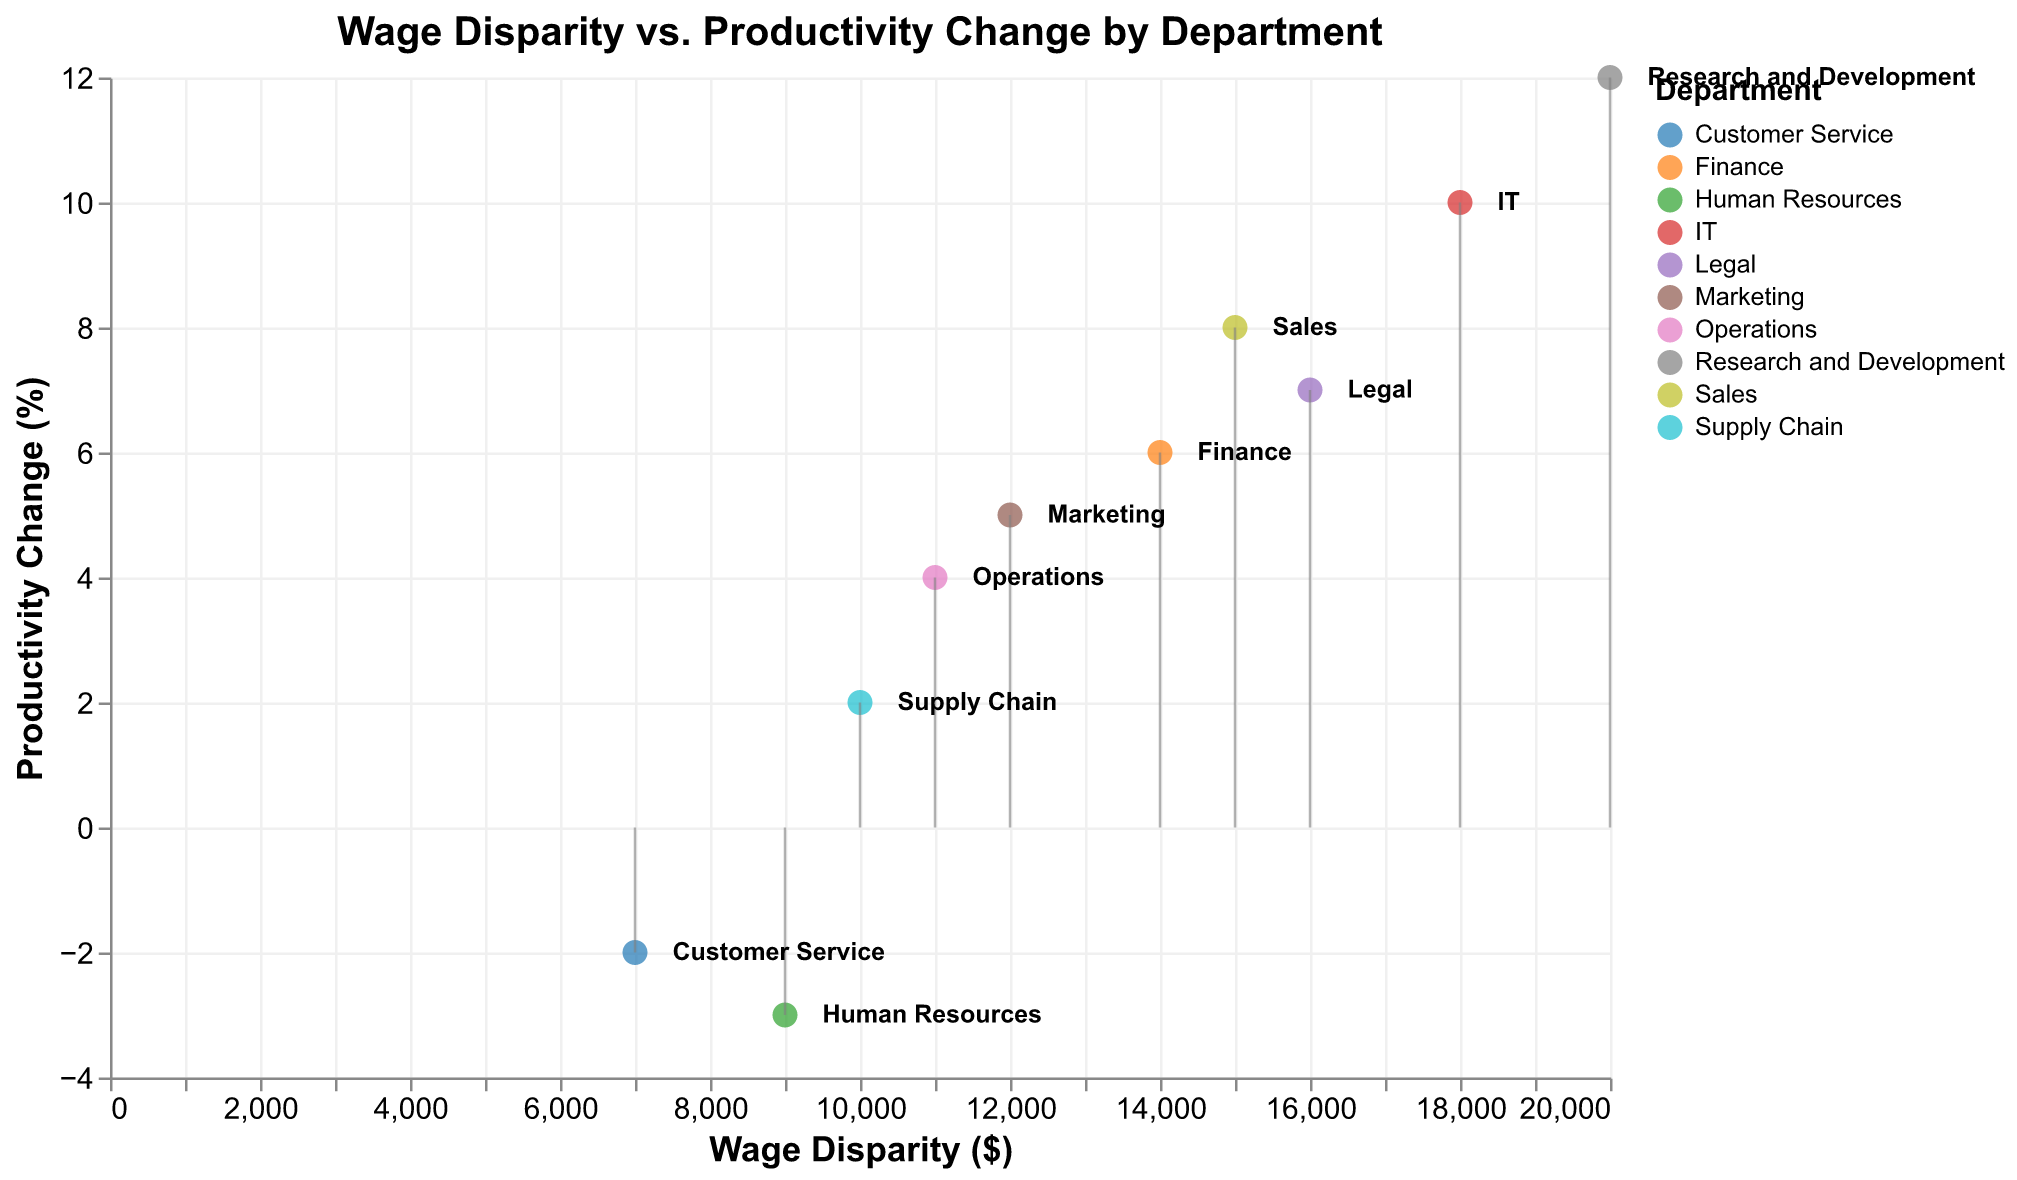What is the title of the figure? The title of the figure is displayed at the top of the graph and it usually provides the main topic or summary of what the figure represents.
Answer: Wage Disparity vs. Productivity Change by Department How many departments are represented in the figure? Count the number of distinct data points or labels on the plot. Each unique label or color represents a department.
Answer: 10 Which department has the highest wage disparity and what is the value? Look for the data point that is furthest to the right on the x-axis, which represents wage disparity, and identify the department.
Answer: Research and Development, $20,000 Which departments indicate a negative productivity change? Look for the data points below the y-axis origin (0%). Identify the labels or colors representing these departments.
Answer: Human Resources, Customer Service What is the productivity change percentage for the Finance department? Locate the point or label representing the Finance department and note its position on the y-axis.
Answer: 6% What is the difference in productivity change between Sales and Marketing departments? Find the y-axis values for both Sales and Marketing, subtract Marketing's value from Sales'.
Answer: 8% - 5% = 3% Do departments with higher wage disparity tend to have higher productivity changes? Observe the general trend or direction from left to right along the x-axis (wage disparity) and note if the points also increase upwards along the y-axis (productivity change).
Answer: Yes, higher wage disparity generally relates to higher productivity changes Which department has the smallest wage disparity among those with a negative productivity change? Among the data points below the y-axis origin, identify the one with the smallest x-axis value.
Answer: Customer Service, $7,000 Compare the productivity change between IT and Operations. Which one has a higher change? Find both points on the plot, compare their positions on the y-axis and identify the one higher up.
Answer: IT, 10% What is the average wage disparity for all departments? Sum all the wage disparity values and divide by the number of departments (10). ($15000 + $12000 + $18000 + $9000 + $14000 + $20000 + $7000 + $11000 + $16000 + $10000) / 10 = $132,000 / 10 = $13,200
Answer: $13,200 